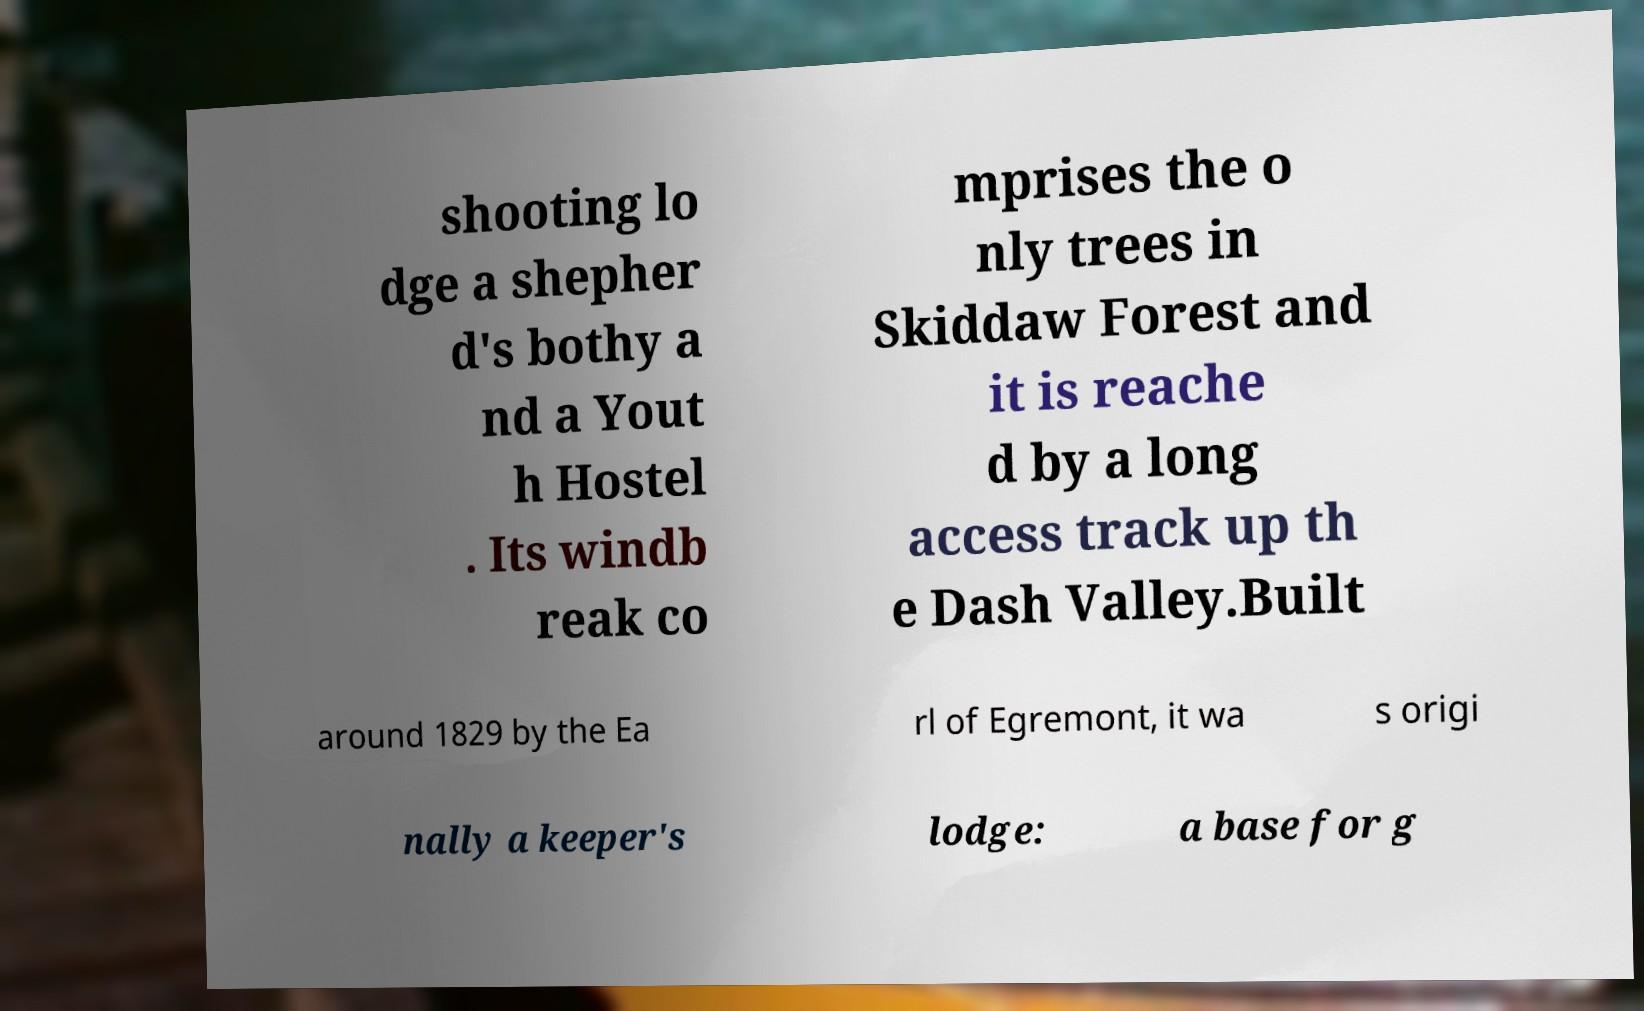There's text embedded in this image that I need extracted. Can you transcribe it verbatim? shooting lo dge a shepher d's bothy a nd a Yout h Hostel . Its windb reak co mprises the o nly trees in Skiddaw Forest and it is reache d by a long access track up th e Dash Valley.Built around 1829 by the Ea rl of Egremont, it wa s origi nally a keeper's lodge: a base for g 